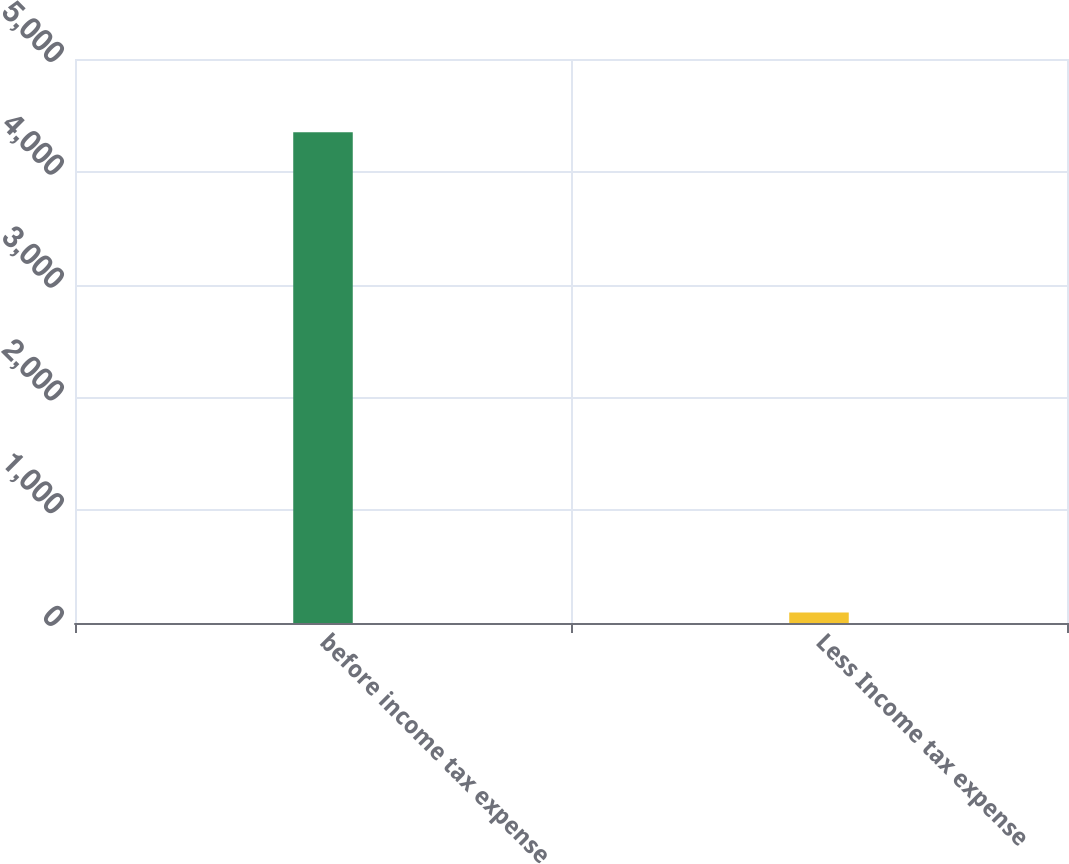Convert chart to OTSL. <chart><loc_0><loc_0><loc_500><loc_500><bar_chart><fcel>before income tax expense<fcel>Less Income tax expense<nl><fcel>4350<fcel>93<nl></chart> 